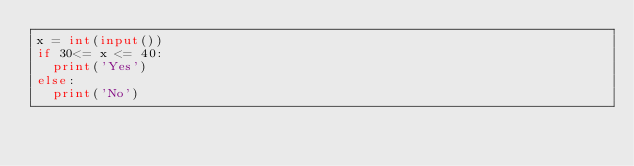<code> <loc_0><loc_0><loc_500><loc_500><_Python_>x = int(input())
if 30<= x <= 40:
  print('Yes')
else:
  print('No')</code> 